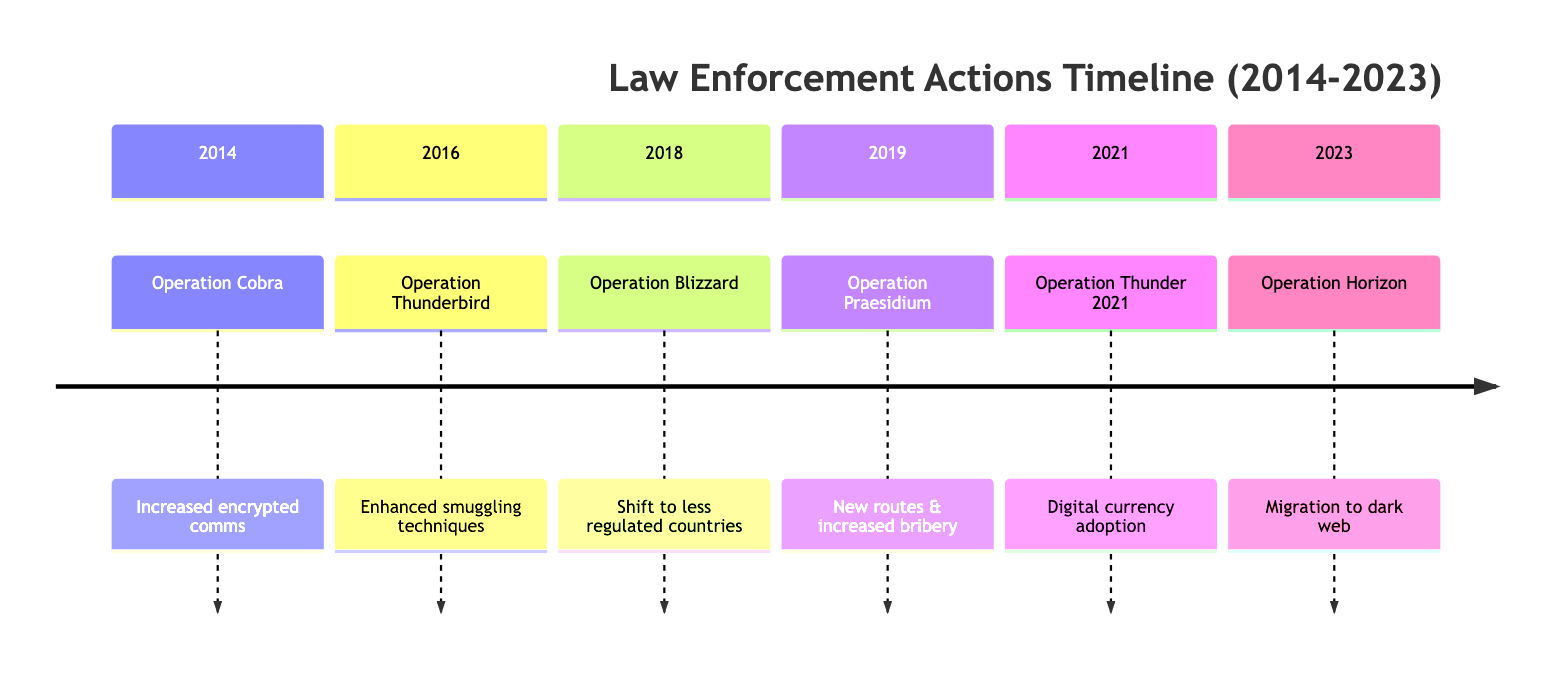What was the first operation listed in the timeline? The timeline starts with "Operation Cobra" in 2014.
Answer: Operation Cobra How many operations occurred between 2014 and 2023? There are six operations listed in the timeline from 2014 to 2023.
Answer: 6 What is the primary response to the events of 2021? The response in 2021 was the adoption of digital currency for transactions.
Answer: Digital currency adoption Which operation led to a significant financial loss due to the seizure of endangered animals? "Operation Thunderbird" in 2016 resulted in significant financial loss.
Answer: Operation Thunderbird What pattern can be observed in the responses from 2014 to 2023? There is a trend of increasing sophistication in smuggling techniques and methods to evade law enforcement.
Answer: Increasing sophistication What was the impact of the final operation in the timeline? The impact of "Operation Horizon" in 2023 was the shutdown of several major online trafficking platforms.
Answer: Shutdown of online platforms Which operation was specifically focused on the illegal reptile trade? "Operation Blizzard" in 2018 was focused on the illegal reptile trade.
Answer: Operation Blizzard Between which years was there an operation targeting ivory trafficking? The operation targeting ivory trafficking, "Operation Praesidium," occurred in 2019.
Answer: 2019 What response followed the operation involving online wildlife trade in 2023? The response was migration to dark web marketplaces and advanced cyber security measures.
Answer: Migration to dark web What trend did the operational responses show over the years? The operational responses showed a trend toward more advanced technology and methods for evading law enforcement.
Answer: Advanced technology and evasion methods 